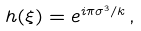Convert formula to latex. <formula><loc_0><loc_0><loc_500><loc_500>h ( \xi ) = e ^ { i \pi \sigma ^ { 3 } / k } \, ,</formula> 